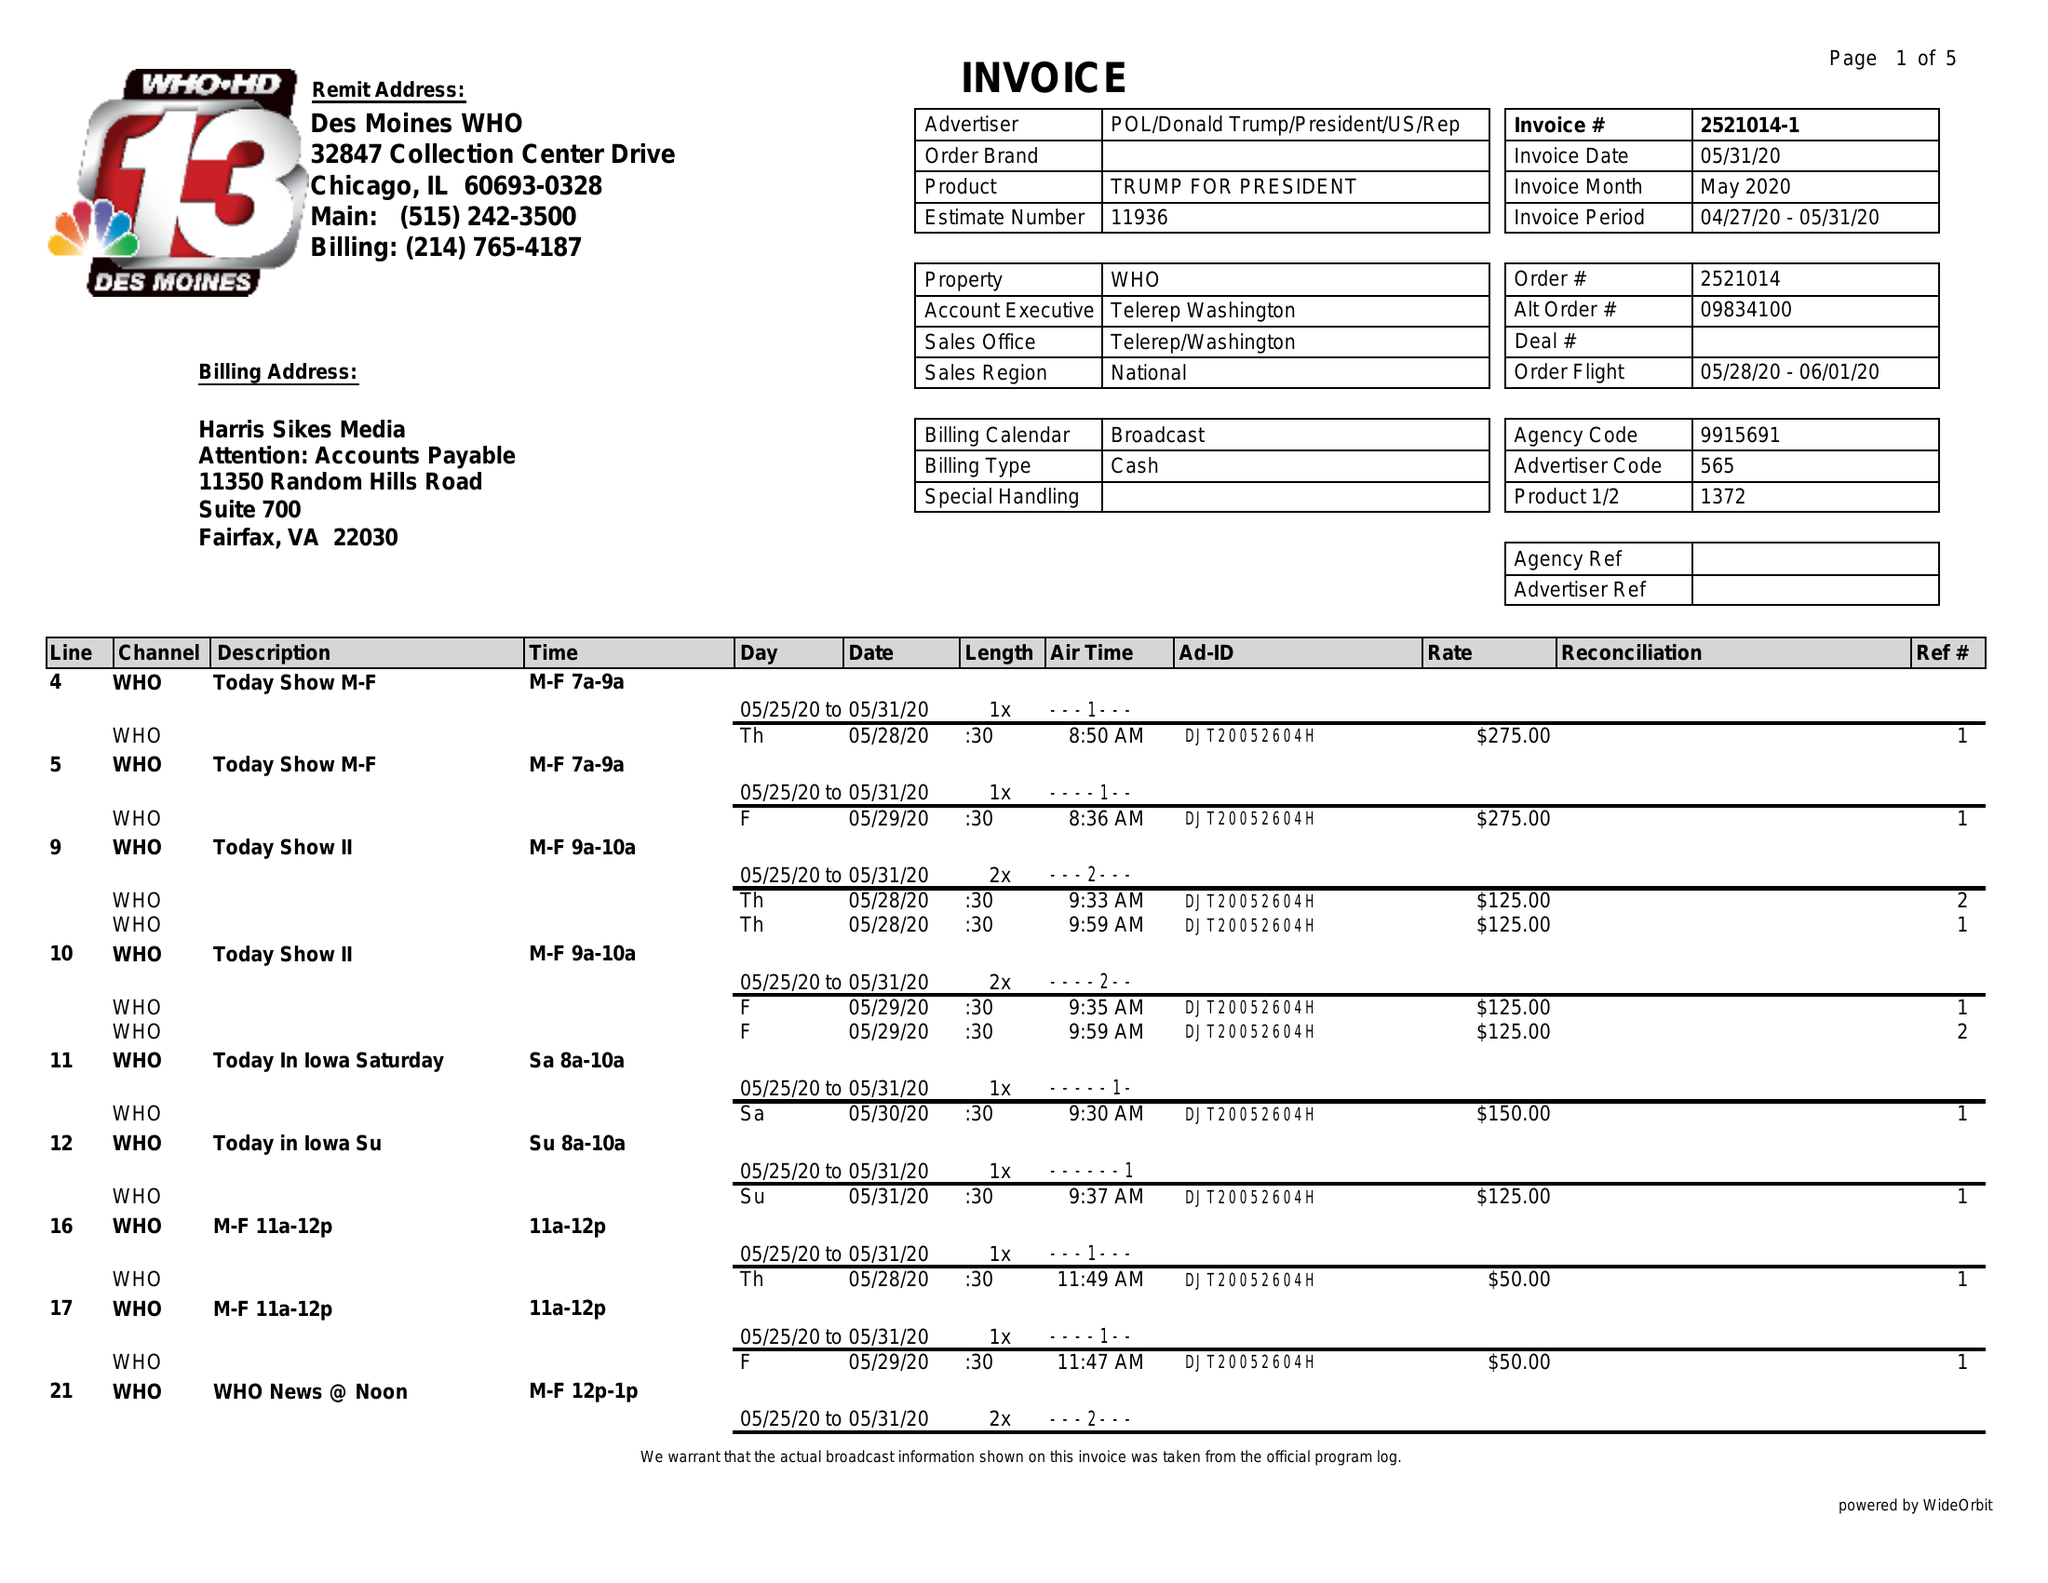What is the value for the contract_num?
Answer the question using a single word or phrase. 2521014 